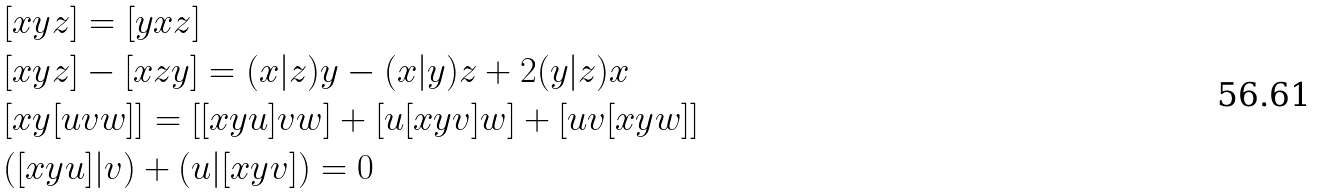Convert formula to latex. <formula><loc_0><loc_0><loc_500><loc_500>& [ x y z ] = [ y x z ] \\ & [ x y z ] - [ x z y ] = ( x | z ) y - ( x | y ) z + 2 ( y | z ) x \\ & [ x y [ u v w ] ] = [ [ x y u ] v w ] + [ u [ x y v ] w ] + [ u v [ x y w ] ] \\ & ( [ x y u ] | v ) + ( u | [ x y v ] ) = 0</formula> 